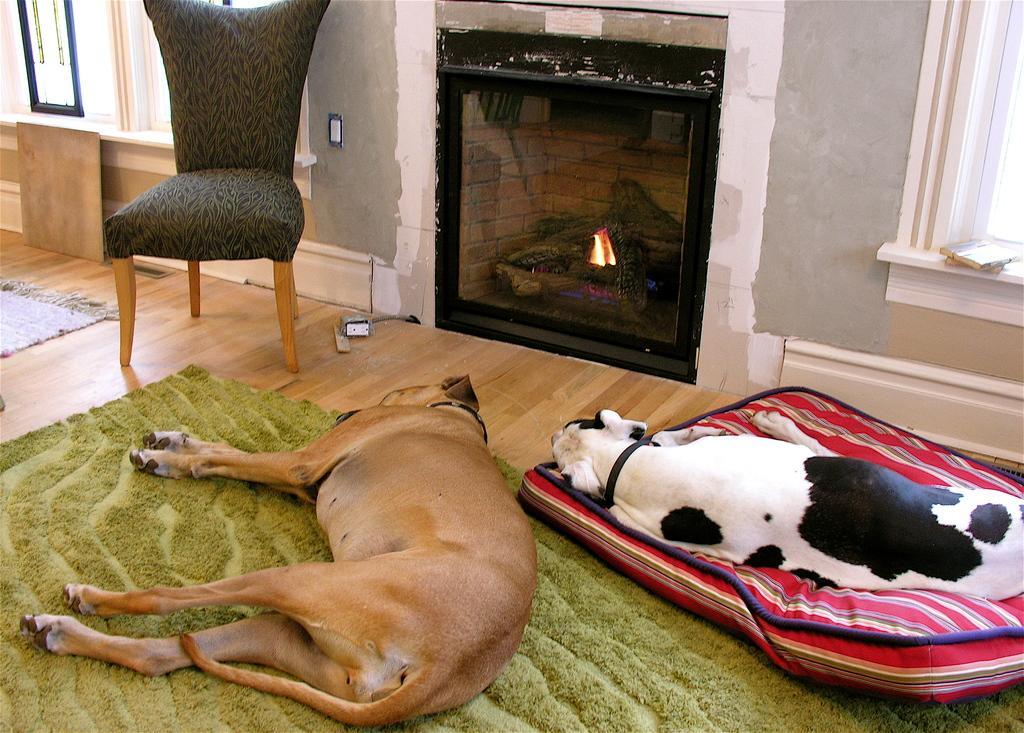Can you describe this image briefly? In this image i can see two dogs which are sleeping on the floor and at the top of the image there is a chair. 